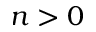Convert formula to latex. <formula><loc_0><loc_0><loc_500><loc_500>n > 0</formula> 